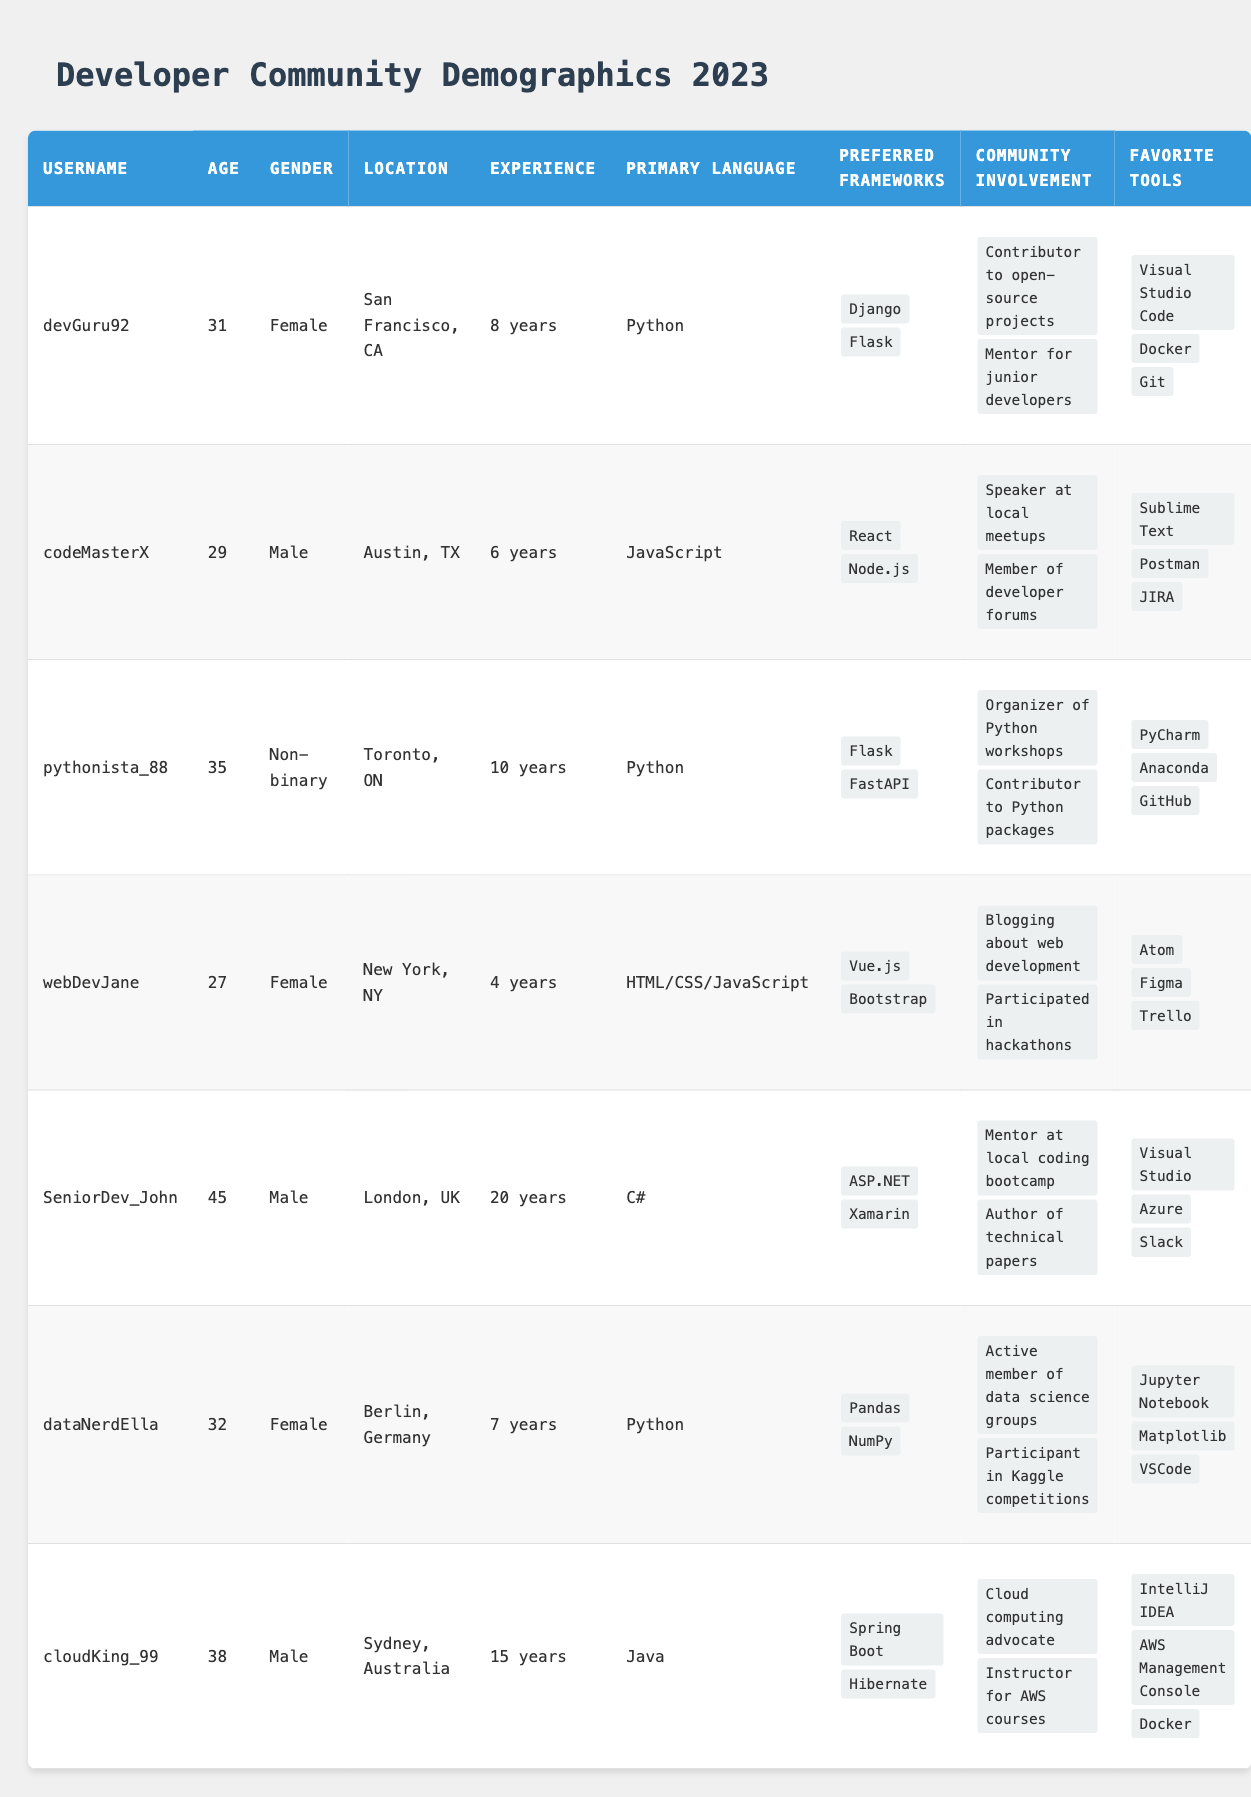What is the age of the user with the username "cloudKing_99"? From the table, locate the row where the username is "cloudKing_99", which shows the user's age in the adjacent cell. The age listed is 38.
Answer: 38 How many years of experience does "SeniorDev_John" have? Find the row corresponding to "SeniorDev_John" and locate the "Experience" column. The entry states that he has 20 years of experience.
Answer: 20 years What is the primary programming language associated with "dataNerdElla"? Check the row for "dataNerdElla" and identify the value in the "Primary Language" column, which is Python.
Answer: Python Is there any user from Berlin, Germany in the community? Review the "Location" column for any instances of "Berlin, Germany". There is one matching entry, confirming the presence of a user from this location.
Answer: Yes Which users have "Python" as their primary language? Look in the "Primary Language" column and list the usernames that match Python: "devGuru92", "pythonista_88", and "dataNerdElla". Three users have Python as their primary language.
Answer: devGuru92, pythonista_88, dataNerdElla What is the median age of users in the community? First, list all the ages from the table: 31, 29, 35, 27, 45, 32, 38. Sorting these gives: 27, 29, 31, 32, 35, 38, 45. The median age, being the middle value, is 32 (the fourth number in a sorted list of 7).
Answer: 32 Who is the youngest user and what is their age? Review the ages in the table and identify the lowest number, which corresponds to the user "webDevJane" with an age of 27.
Answer: webDevJane, 27 How many users have at least 10 years of experience? Check the "Experience" column for users with 10 years or more: "pythonista_88" and "SeniorDev_John". This counts as 2 users.
Answer: 2 Which gender has the highest representation in this community? Count the occurrences of each gender from the "Gender" column: Male (3), Female (3), Non-binary (1). Both Male and Female have the highest representation with 3 users each.
Answer: Male and Female 